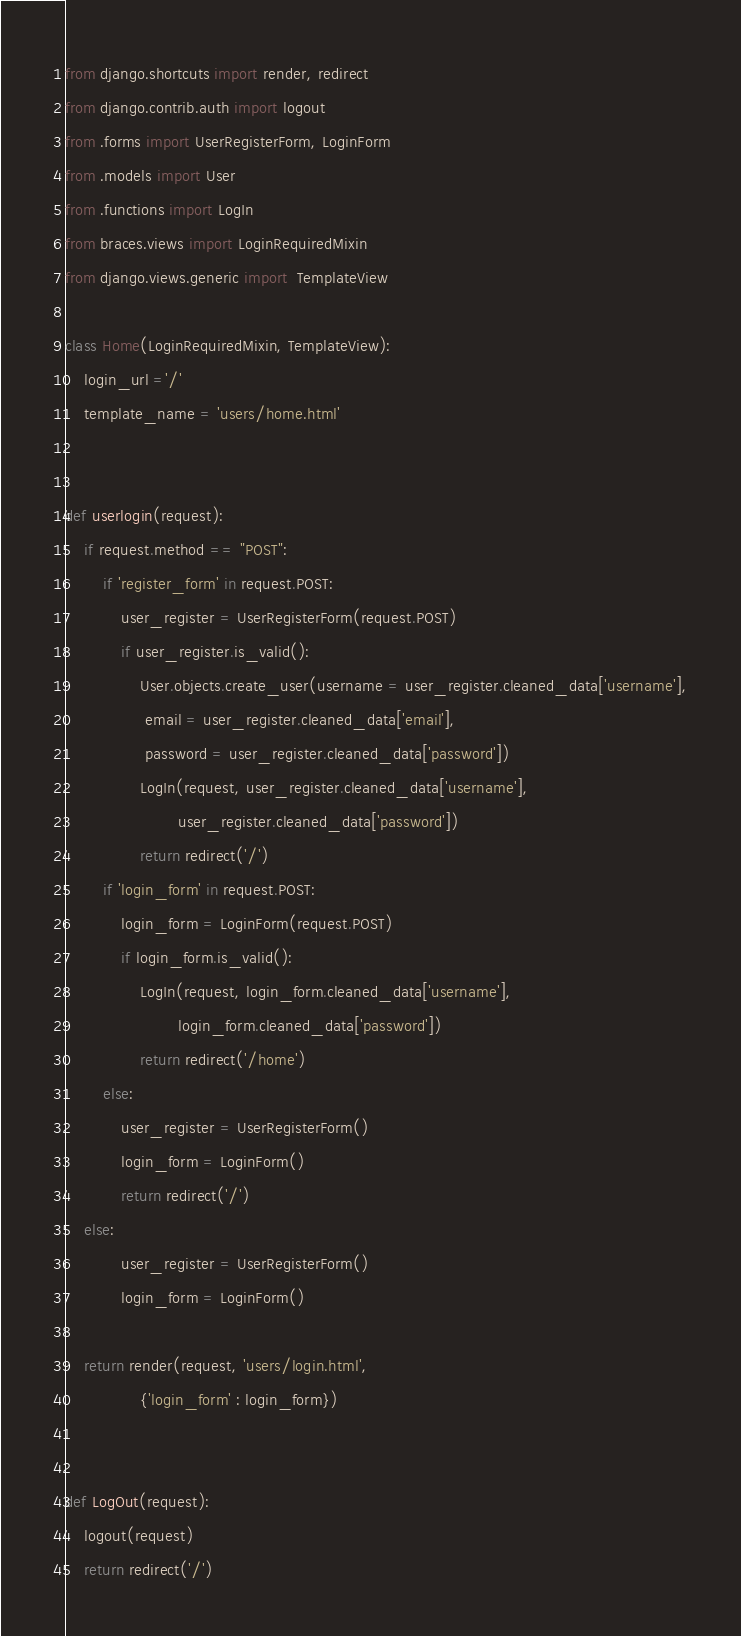<code> <loc_0><loc_0><loc_500><loc_500><_Python_>from django.shortcuts import render, redirect
from django.contrib.auth import logout
from .forms import UserRegisterForm, LoginForm
from .models import User
from .functions import LogIn
from braces.views import LoginRequiredMixin
from django.views.generic import  TemplateView

class Home(LoginRequiredMixin, TemplateView):
	login_url ='/'
	template_name = 'users/home.html'


def userlogin(request):
	if request.method == "POST":
		if 'register_form' in request.POST:
			user_register = UserRegisterForm(request.POST)
			if user_register.is_valid():
				User.objects.create_user(username = user_register.cleaned_data['username'],
				 email = user_register.cleaned_data['email'], 
				 password = user_register.cleaned_data['password'])
				LogIn(request, user_register.cleaned_data['username'],
						user_register.cleaned_data['password'])
				return redirect('/')
		if 'login_form' in request.POST:
			login_form = LoginForm(request.POST)
			if login_form.is_valid():
				LogIn(request, login_form.cleaned_data['username'],
						login_form.cleaned_data['password'])
				return redirect('/home')
		else:
			user_register = UserRegisterForm()
			login_form = LoginForm()
			return redirect('/')
	else:
			user_register = UserRegisterForm()
			login_form = LoginForm()
			
	return render(request, 'users/login.html', 
				{'login_form' : login_form})


def LogOut(request):
	logout(request)
	return redirect('/')</code> 